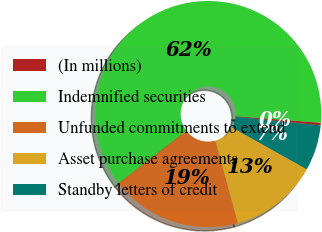<chart> <loc_0><loc_0><loc_500><loc_500><pie_chart><fcel>(In millions)<fcel>Indemnified securities<fcel>Unfunded commitments to extend<fcel>Asset purchase agreements<fcel>Standby letters of credit<nl><fcel>0.37%<fcel>61.71%<fcel>18.77%<fcel>12.64%<fcel>6.51%<nl></chart> 